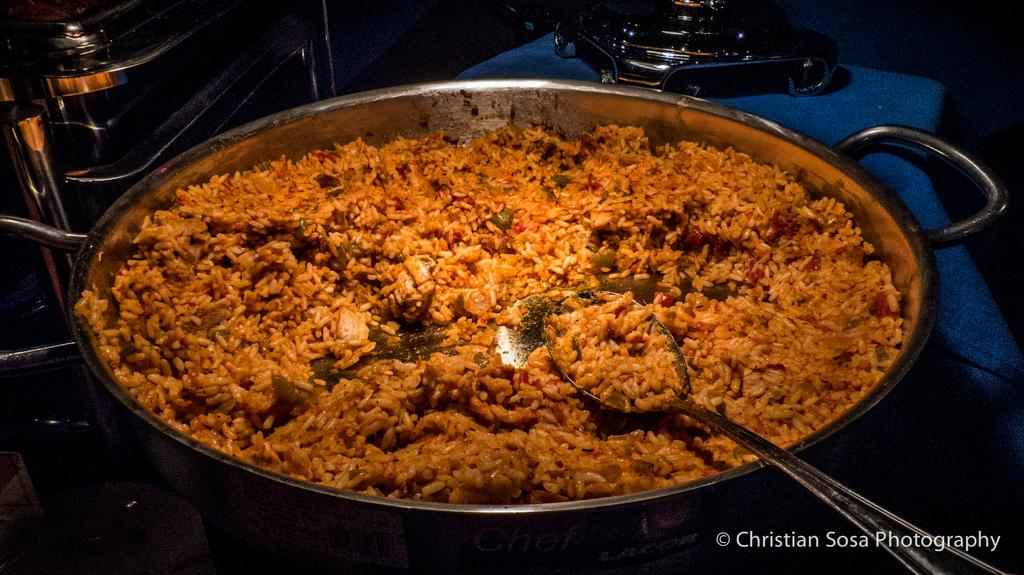Where was the image taken? The image was taken indoors. What is in the utensil that is the main focus of the image? There is a utensil with rice and a spoon in it. Can you describe any other utensils visible in the image? There are a few utensils in the background. What channel is the TV tuned to in the image? There is no TV present in the image, so it is not possible to determine the channel. 